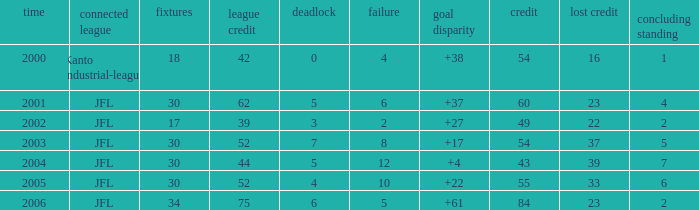Tell me the highest matches for point 43 and final rank less than 7 None. 